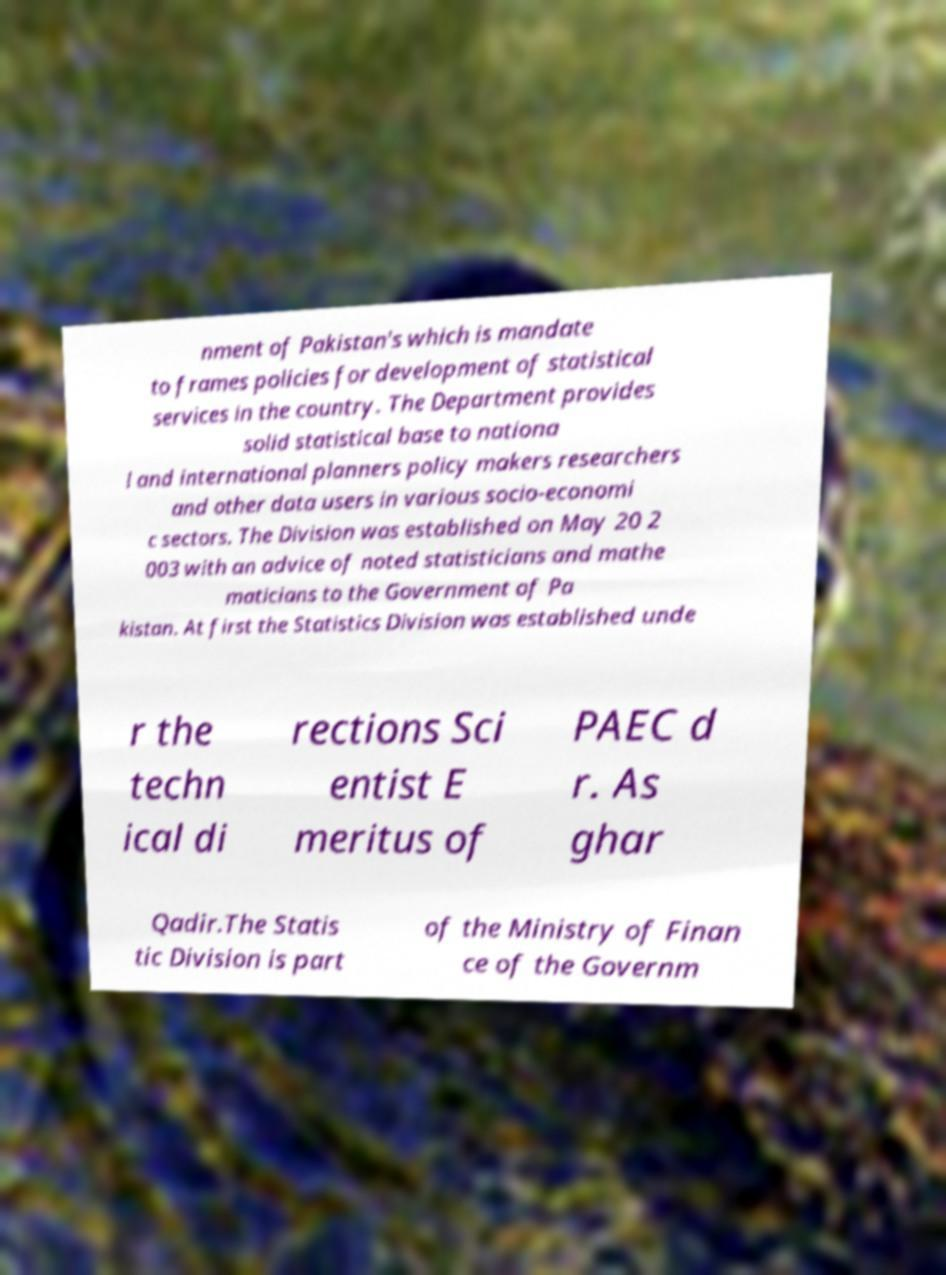I need the written content from this picture converted into text. Can you do that? nment of Pakistan's which is mandate to frames policies for development of statistical services in the country. The Department provides solid statistical base to nationa l and international planners policy makers researchers and other data users in various socio-economi c sectors. The Division was established on May 20 2 003 with an advice of noted statisticians and mathe maticians to the Government of Pa kistan. At first the Statistics Division was established unde r the techn ical di rections Sci entist E meritus of PAEC d r. As ghar Qadir.The Statis tic Division is part of the Ministry of Finan ce of the Governm 